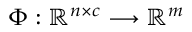<formula> <loc_0><loc_0><loc_500><loc_500>\Phi \colon \mathbb { R } ^ { n \times c } \longrightarrow \mathbb { R } ^ { m }</formula> 